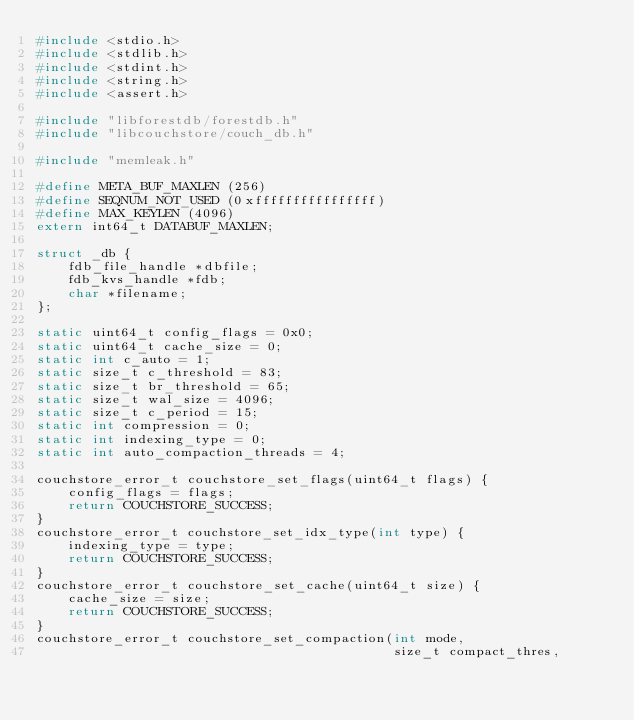<code> <loc_0><loc_0><loc_500><loc_500><_C++_>#include <stdio.h>
#include <stdlib.h>
#include <stdint.h>
#include <string.h>
#include <assert.h>

#include "libforestdb/forestdb.h"
#include "libcouchstore/couch_db.h"

#include "memleak.h"

#define META_BUF_MAXLEN (256)
#define SEQNUM_NOT_USED (0xffffffffffffffff)
#define MAX_KEYLEN (4096)
extern int64_t DATABUF_MAXLEN;

struct _db {
    fdb_file_handle *dbfile;
    fdb_kvs_handle *fdb;
    char *filename;
};

static uint64_t config_flags = 0x0;
static uint64_t cache_size = 0;
static int c_auto = 1;
static size_t c_threshold = 83;
static size_t br_threshold = 65;
static size_t wal_size = 4096;
static size_t c_period = 15;
static int compression = 0;
static int indexing_type = 0;
static int auto_compaction_threads = 4;

couchstore_error_t couchstore_set_flags(uint64_t flags) {
    config_flags = flags;
    return COUCHSTORE_SUCCESS;
}
couchstore_error_t couchstore_set_idx_type(int type) {
    indexing_type = type;
    return COUCHSTORE_SUCCESS;
}
couchstore_error_t couchstore_set_cache(uint64_t size) {
    cache_size = size;
    return COUCHSTORE_SUCCESS;
}
couchstore_error_t couchstore_set_compaction(int mode,
                                             size_t compact_thres,</code> 